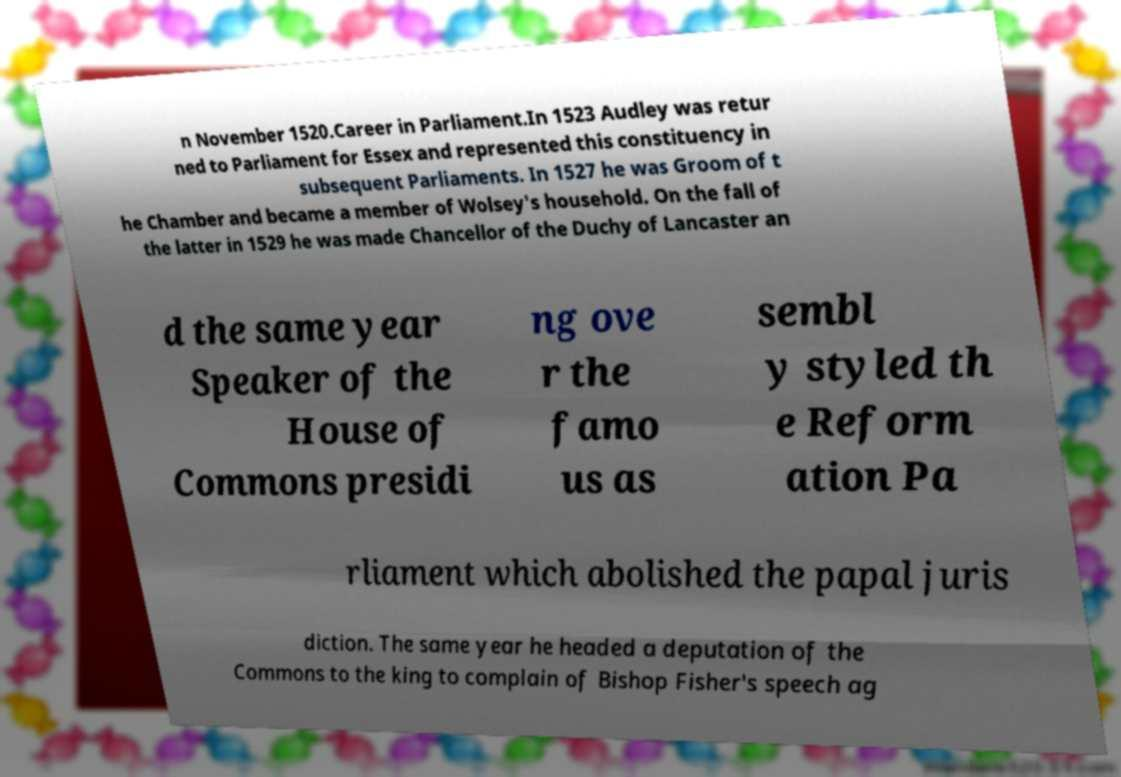For documentation purposes, I need the text within this image transcribed. Could you provide that? n November 1520.Career in Parliament.In 1523 Audley was retur ned to Parliament for Essex and represented this constituency in subsequent Parliaments. In 1527 he was Groom of t he Chamber and became a member of Wolsey's household. On the fall of the latter in 1529 he was made Chancellor of the Duchy of Lancaster an d the same year Speaker of the House of Commons presidi ng ove r the famo us as sembl y styled th e Reform ation Pa rliament which abolished the papal juris diction. The same year he headed a deputation of the Commons to the king to complain of Bishop Fisher's speech ag 